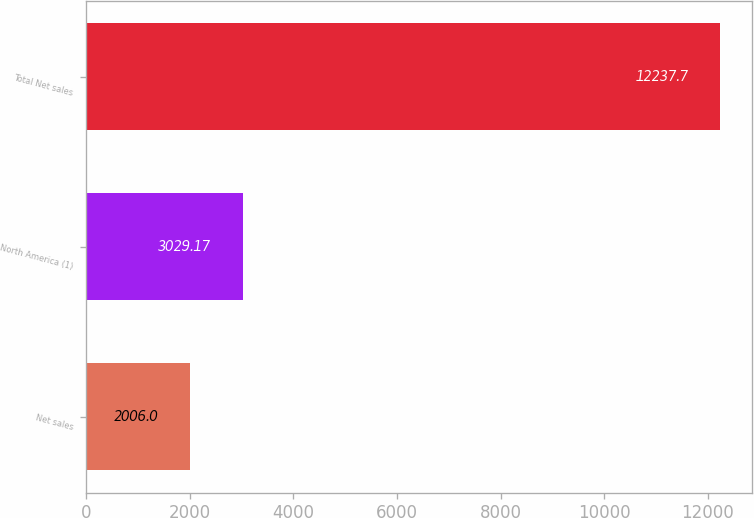Convert chart. <chart><loc_0><loc_0><loc_500><loc_500><bar_chart><fcel>Net sales<fcel>North America (1)<fcel>Total Net sales<nl><fcel>2006<fcel>3029.17<fcel>12237.7<nl></chart> 